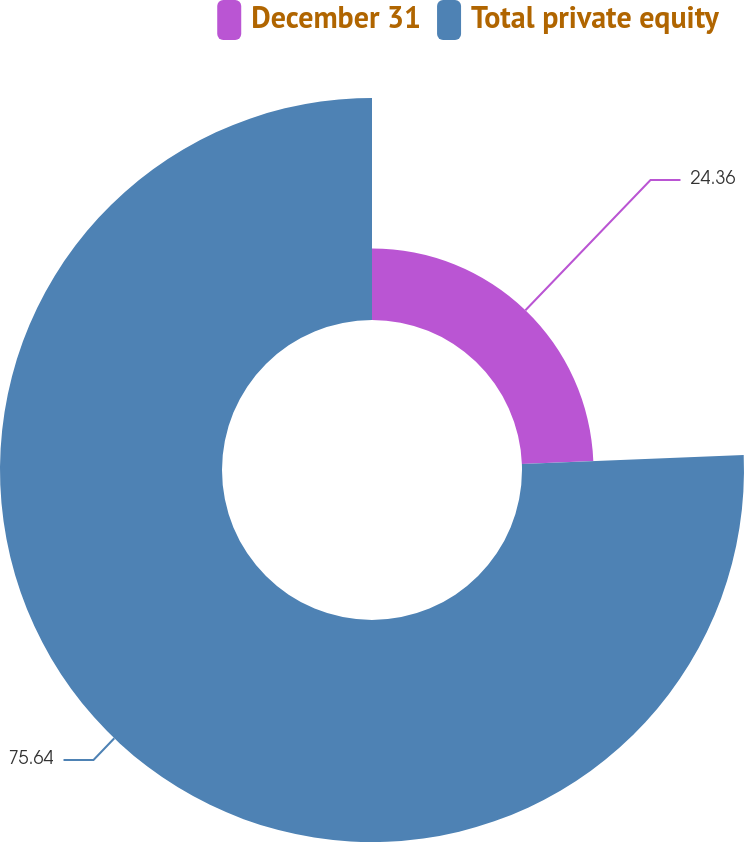Convert chart. <chart><loc_0><loc_0><loc_500><loc_500><pie_chart><fcel>December 31<fcel>Total private equity<nl><fcel>24.36%<fcel>75.64%<nl></chart> 